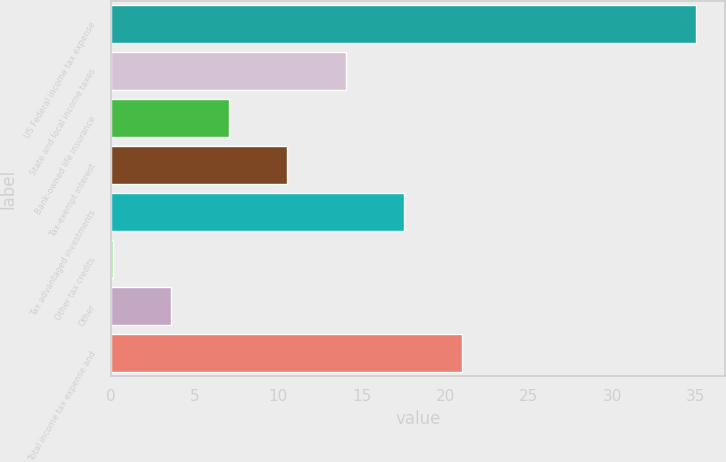Convert chart. <chart><loc_0><loc_0><loc_500><loc_500><bar_chart><fcel>US Federal income tax expense<fcel>State and local income taxes<fcel>Bank-owned life insurance<fcel>Tax-exempt interest<fcel>Tax advantaged investments<fcel>Other tax credits<fcel>Other<fcel>Total income tax expense and<nl><fcel>35<fcel>14.06<fcel>7.08<fcel>10.57<fcel>17.55<fcel>0.1<fcel>3.59<fcel>21.04<nl></chart> 